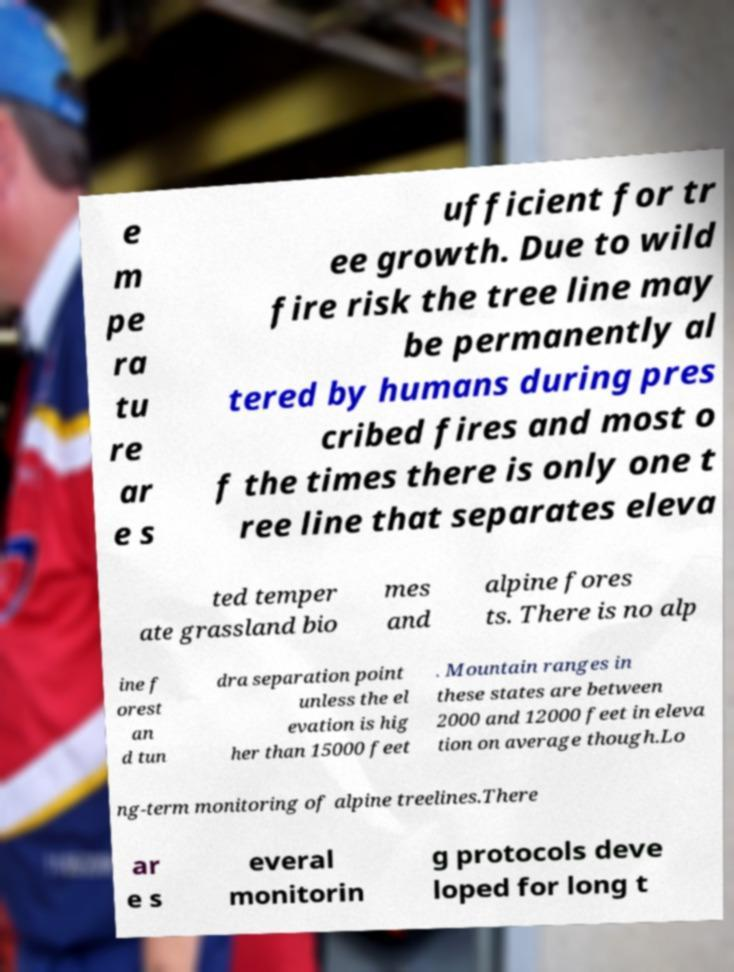For documentation purposes, I need the text within this image transcribed. Could you provide that? e m pe ra tu re ar e s ufficient for tr ee growth. Due to wild fire risk the tree line may be permanently al tered by humans during pres cribed fires and most o f the times there is only one t ree line that separates eleva ted temper ate grassland bio mes and alpine fores ts. There is no alp ine f orest an d tun dra separation point unless the el evation is hig her than 15000 feet . Mountain ranges in these states are between 2000 and 12000 feet in eleva tion on average though.Lo ng-term monitoring of alpine treelines.There ar e s everal monitorin g protocols deve loped for long t 